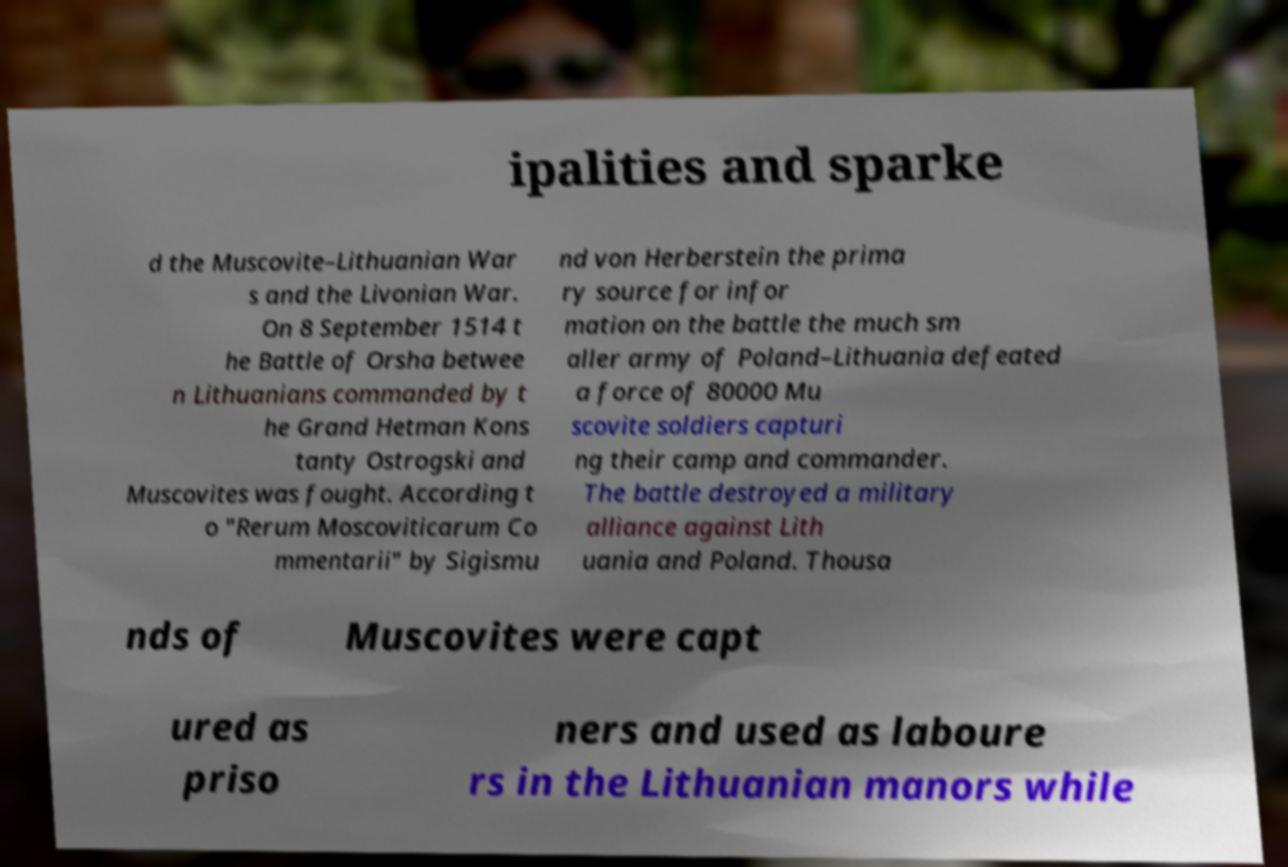Please identify and transcribe the text found in this image. ipalities and sparke d the Muscovite–Lithuanian War s and the Livonian War. On 8 September 1514 t he Battle of Orsha betwee n Lithuanians commanded by t he Grand Hetman Kons tanty Ostrogski and Muscovites was fought. According t o "Rerum Moscoviticarum Co mmentarii" by Sigismu nd von Herberstein the prima ry source for infor mation on the battle the much sm aller army of Poland–Lithuania defeated a force of 80000 Mu scovite soldiers capturi ng their camp and commander. The battle destroyed a military alliance against Lith uania and Poland. Thousa nds of Muscovites were capt ured as priso ners and used as laboure rs in the Lithuanian manors while 